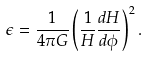Convert formula to latex. <formula><loc_0><loc_0><loc_500><loc_500>\epsilon = \frac { 1 } { 4 \pi G } \left ( \frac { 1 } { H } \frac { d H } { d \phi } \right ) ^ { 2 } .</formula> 